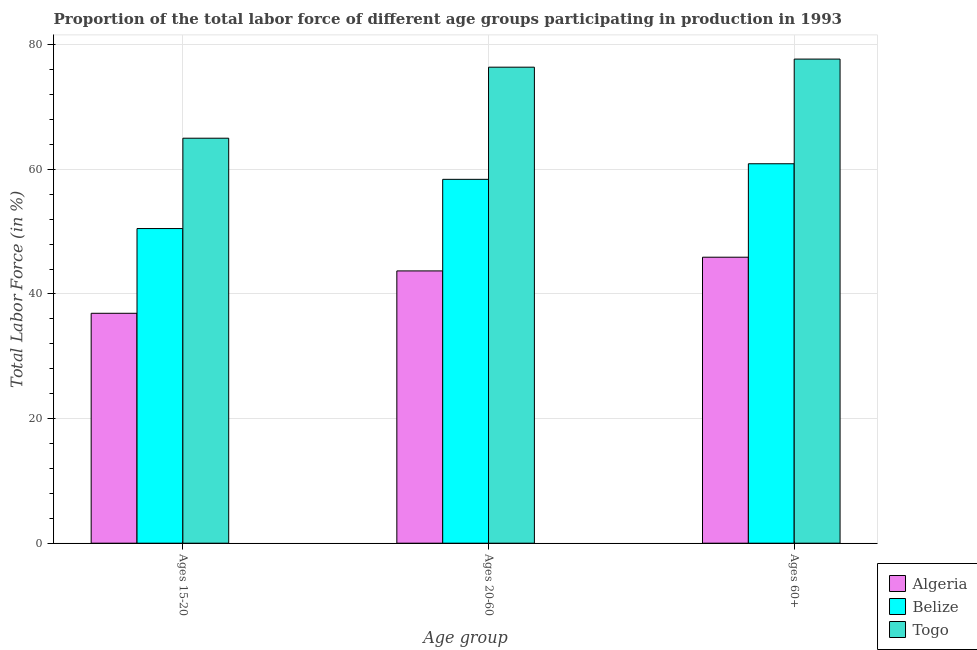How many groups of bars are there?
Make the answer very short. 3. Are the number of bars per tick equal to the number of legend labels?
Keep it short and to the point. Yes. How many bars are there on the 1st tick from the left?
Offer a terse response. 3. How many bars are there on the 1st tick from the right?
Provide a short and direct response. 3. What is the label of the 1st group of bars from the left?
Offer a terse response. Ages 15-20. What is the percentage of labor force above age 60 in Togo?
Your answer should be compact. 77.7. Across all countries, what is the maximum percentage of labor force within the age group 20-60?
Keep it short and to the point. 76.4. Across all countries, what is the minimum percentage of labor force above age 60?
Offer a terse response. 45.9. In which country was the percentage of labor force within the age group 20-60 maximum?
Your answer should be compact. Togo. In which country was the percentage of labor force above age 60 minimum?
Make the answer very short. Algeria. What is the total percentage of labor force above age 60 in the graph?
Provide a short and direct response. 184.5. What is the difference between the percentage of labor force within the age group 15-20 in Algeria and that in Belize?
Your answer should be compact. -13.6. What is the difference between the percentage of labor force within the age group 20-60 in Algeria and the percentage of labor force within the age group 15-20 in Belize?
Make the answer very short. -6.8. What is the average percentage of labor force within the age group 15-20 per country?
Keep it short and to the point. 50.8. What is the difference between the percentage of labor force within the age group 15-20 and percentage of labor force within the age group 20-60 in Belize?
Provide a short and direct response. -7.9. In how many countries, is the percentage of labor force within the age group 15-20 greater than 12 %?
Provide a succinct answer. 3. What is the ratio of the percentage of labor force above age 60 in Togo to that in Belize?
Provide a short and direct response. 1.28. Is the percentage of labor force within the age group 15-20 in Togo less than that in Algeria?
Offer a very short reply. No. What is the difference between the highest and the second highest percentage of labor force above age 60?
Offer a very short reply. 16.8. What is the difference between the highest and the lowest percentage of labor force within the age group 20-60?
Your response must be concise. 32.7. Is the sum of the percentage of labor force above age 60 in Belize and Algeria greater than the maximum percentage of labor force within the age group 15-20 across all countries?
Provide a succinct answer. Yes. What does the 3rd bar from the left in Ages 15-20 represents?
Make the answer very short. Togo. What does the 2nd bar from the right in Ages 60+ represents?
Your answer should be compact. Belize. How many countries are there in the graph?
Keep it short and to the point. 3. Are the values on the major ticks of Y-axis written in scientific E-notation?
Offer a very short reply. No. Does the graph contain any zero values?
Ensure brevity in your answer.  No. Where does the legend appear in the graph?
Offer a terse response. Bottom right. How are the legend labels stacked?
Your response must be concise. Vertical. What is the title of the graph?
Your answer should be very brief. Proportion of the total labor force of different age groups participating in production in 1993. Does "High income" appear as one of the legend labels in the graph?
Your answer should be compact. No. What is the label or title of the X-axis?
Provide a short and direct response. Age group. What is the label or title of the Y-axis?
Provide a succinct answer. Total Labor Force (in %). What is the Total Labor Force (in %) in Algeria in Ages 15-20?
Your answer should be compact. 36.9. What is the Total Labor Force (in %) of Belize in Ages 15-20?
Your answer should be compact. 50.5. What is the Total Labor Force (in %) of Togo in Ages 15-20?
Your answer should be compact. 65. What is the Total Labor Force (in %) of Algeria in Ages 20-60?
Your response must be concise. 43.7. What is the Total Labor Force (in %) of Belize in Ages 20-60?
Ensure brevity in your answer.  58.4. What is the Total Labor Force (in %) in Togo in Ages 20-60?
Your answer should be very brief. 76.4. What is the Total Labor Force (in %) of Algeria in Ages 60+?
Your response must be concise. 45.9. What is the Total Labor Force (in %) in Belize in Ages 60+?
Offer a very short reply. 60.9. What is the Total Labor Force (in %) in Togo in Ages 60+?
Provide a succinct answer. 77.7. Across all Age group, what is the maximum Total Labor Force (in %) in Algeria?
Your response must be concise. 45.9. Across all Age group, what is the maximum Total Labor Force (in %) in Belize?
Keep it short and to the point. 60.9. Across all Age group, what is the maximum Total Labor Force (in %) of Togo?
Give a very brief answer. 77.7. Across all Age group, what is the minimum Total Labor Force (in %) of Algeria?
Your answer should be very brief. 36.9. Across all Age group, what is the minimum Total Labor Force (in %) of Belize?
Offer a terse response. 50.5. Across all Age group, what is the minimum Total Labor Force (in %) in Togo?
Provide a succinct answer. 65. What is the total Total Labor Force (in %) in Algeria in the graph?
Provide a succinct answer. 126.5. What is the total Total Labor Force (in %) of Belize in the graph?
Ensure brevity in your answer.  169.8. What is the total Total Labor Force (in %) of Togo in the graph?
Provide a short and direct response. 219.1. What is the difference between the Total Labor Force (in %) of Algeria in Ages 15-20 and that in Ages 20-60?
Make the answer very short. -6.8. What is the difference between the Total Labor Force (in %) in Belize in Ages 15-20 and that in Ages 20-60?
Provide a succinct answer. -7.9. What is the difference between the Total Labor Force (in %) in Togo in Ages 15-20 and that in Ages 20-60?
Keep it short and to the point. -11.4. What is the difference between the Total Labor Force (in %) in Belize in Ages 15-20 and that in Ages 60+?
Make the answer very short. -10.4. What is the difference between the Total Labor Force (in %) of Togo in Ages 15-20 and that in Ages 60+?
Give a very brief answer. -12.7. What is the difference between the Total Labor Force (in %) in Algeria in Ages 20-60 and that in Ages 60+?
Keep it short and to the point. -2.2. What is the difference between the Total Labor Force (in %) in Algeria in Ages 15-20 and the Total Labor Force (in %) in Belize in Ages 20-60?
Provide a short and direct response. -21.5. What is the difference between the Total Labor Force (in %) in Algeria in Ages 15-20 and the Total Labor Force (in %) in Togo in Ages 20-60?
Offer a terse response. -39.5. What is the difference between the Total Labor Force (in %) of Belize in Ages 15-20 and the Total Labor Force (in %) of Togo in Ages 20-60?
Provide a short and direct response. -25.9. What is the difference between the Total Labor Force (in %) of Algeria in Ages 15-20 and the Total Labor Force (in %) of Belize in Ages 60+?
Provide a succinct answer. -24. What is the difference between the Total Labor Force (in %) of Algeria in Ages 15-20 and the Total Labor Force (in %) of Togo in Ages 60+?
Offer a very short reply. -40.8. What is the difference between the Total Labor Force (in %) of Belize in Ages 15-20 and the Total Labor Force (in %) of Togo in Ages 60+?
Ensure brevity in your answer.  -27.2. What is the difference between the Total Labor Force (in %) in Algeria in Ages 20-60 and the Total Labor Force (in %) in Belize in Ages 60+?
Give a very brief answer. -17.2. What is the difference between the Total Labor Force (in %) in Algeria in Ages 20-60 and the Total Labor Force (in %) in Togo in Ages 60+?
Make the answer very short. -34. What is the difference between the Total Labor Force (in %) in Belize in Ages 20-60 and the Total Labor Force (in %) in Togo in Ages 60+?
Offer a very short reply. -19.3. What is the average Total Labor Force (in %) in Algeria per Age group?
Make the answer very short. 42.17. What is the average Total Labor Force (in %) in Belize per Age group?
Your response must be concise. 56.6. What is the average Total Labor Force (in %) of Togo per Age group?
Provide a short and direct response. 73.03. What is the difference between the Total Labor Force (in %) in Algeria and Total Labor Force (in %) in Belize in Ages 15-20?
Offer a very short reply. -13.6. What is the difference between the Total Labor Force (in %) of Algeria and Total Labor Force (in %) of Togo in Ages 15-20?
Keep it short and to the point. -28.1. What is the difference between the Total Labor Force (in %) of Algeria and Total Labor Force (in %) of Belize in Ages 20-60?
Offer a terse response. -14.7. What is the difference between the Total Labor Force (in %) in Algeria and Total Labor Force (in %) in Togo in Ages 20-60?
Make the answer very short. -32.7. What is the difference between the Total Labor Force (in %) of Belize and Total Labor Force (in %) of Togo in Ages 20-60?
Your answer should be very brief. -18. What is the difference between the Total Labor Force (in %) in Algeria and Total Labor Force (in %) in Togo in Ages 60+?
Your answer should be very brief. -31.8. What is the difference between the Total Labor Force (in %) of Belize and Total Labor Force (in %) of Togo in Ages 60+?
Offer a terse response. -16.8. What is the ratio of the Total Labor Force (in %) in Algeria in Ages 15-20 to that in Ages 20-60?
Your response must be concise. 0.84. What is the ratio of the Total Labor Force (in %) in Belize in Ages 15-20 to that in Ages 20-60?
Provide a short and direct response. 0.86. What is the ratio of the Total Labor Force (in %) in Togo in Ages 15-20 to that in Ages 20-60?
Keep it short and to the point. 0.85. What is the ratio of the Total Labor Force (in %) of Algeria in Ages 15-20 to that in Ages 60+?
Your answer should be very brief. 0.8. What is the ratio of the Total Labor Force (in %) of Belize in Ages 15-20 to that in Ages 60+?
Offer a very short reply. 0.83. What is the ratio of the Total Labor Force (in %) of Togo in Ages 15-20 to that in Ages 60+?
Make the answer very short. 0.84. What is the ratio of the Total Labor Force (in %) of Algeria in Ages 20-60 to that in Ages 60+?
Your answer should be very brief. 0.95. What is the ratio of the Total Labor Force (in %) of Belize in Ages 20-60 to that in Ages 60+?
Provide a succinct answer. 0.96. What is the ratio of the Total Labor Force (in %) in Togo in Ages 20-60 to that in Ages 60+?
Keep it short and to the point. 0.98. What is the difference between the highest and the second highest Total Labor Force (in %) in Togo?
Give a very brief answer. 1.3. What is the difference between the highest and the lowest Total Labor Force (in %) in Belize?
Keep it short and to the point. 10.4. 